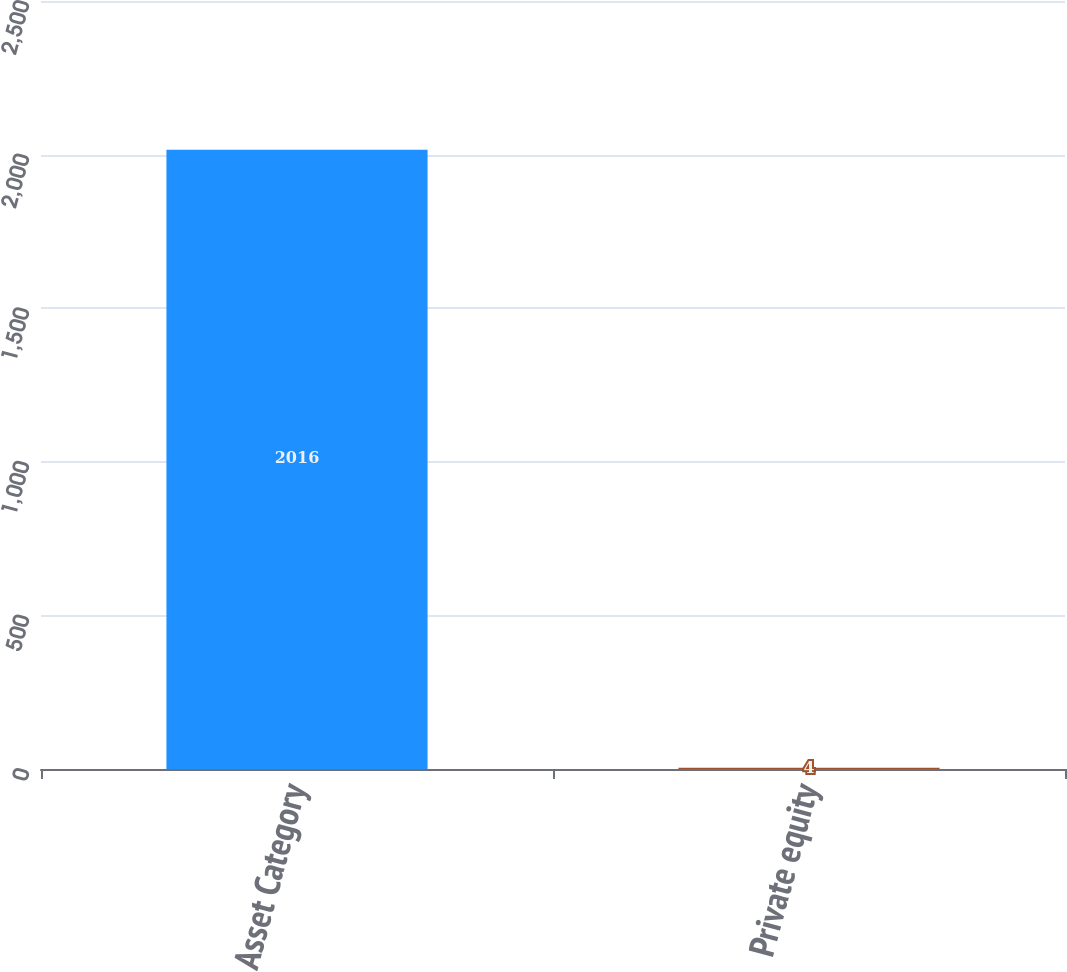Convert chart. <chart><loc_0><loc_0><loc_500><loc_500><bar_chart><fcel>Asset Category<fcel>Private equity<nl><fcel>2016<fcel>4<nl></chart> 